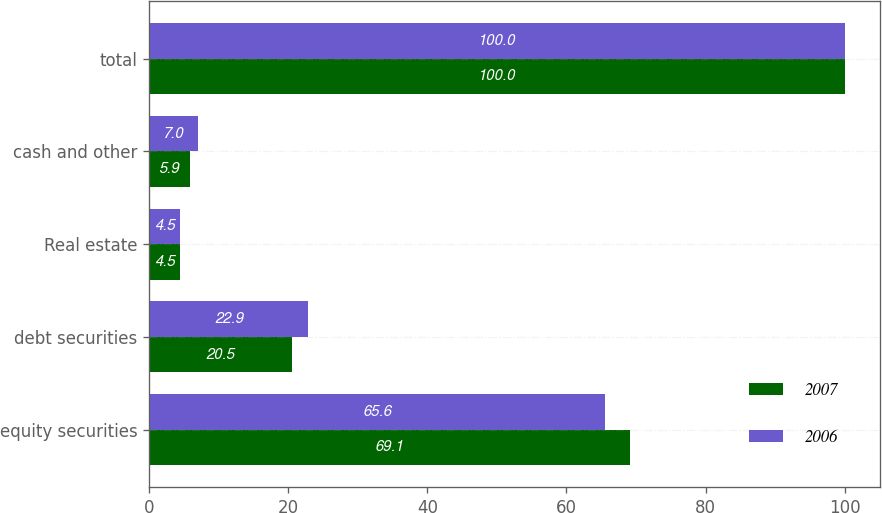Convert chart. <chart><loc_0><loc_0><loc_500><loc_500><stacked_bar_chart><ecel><fcel>equity securities<fcel>debt securities<fcel>Real estate<fcel>cash and other<fcel>total<nl><fcel>2007<fcel>69.1<fcel>20.5<fcel>4.5<fcel>5.9<fcel>100<nl><fcel>2006<fcel>65.6<fcel>22.9<fcel>4.5<fcel>7<fcel>100<nl></chart> 